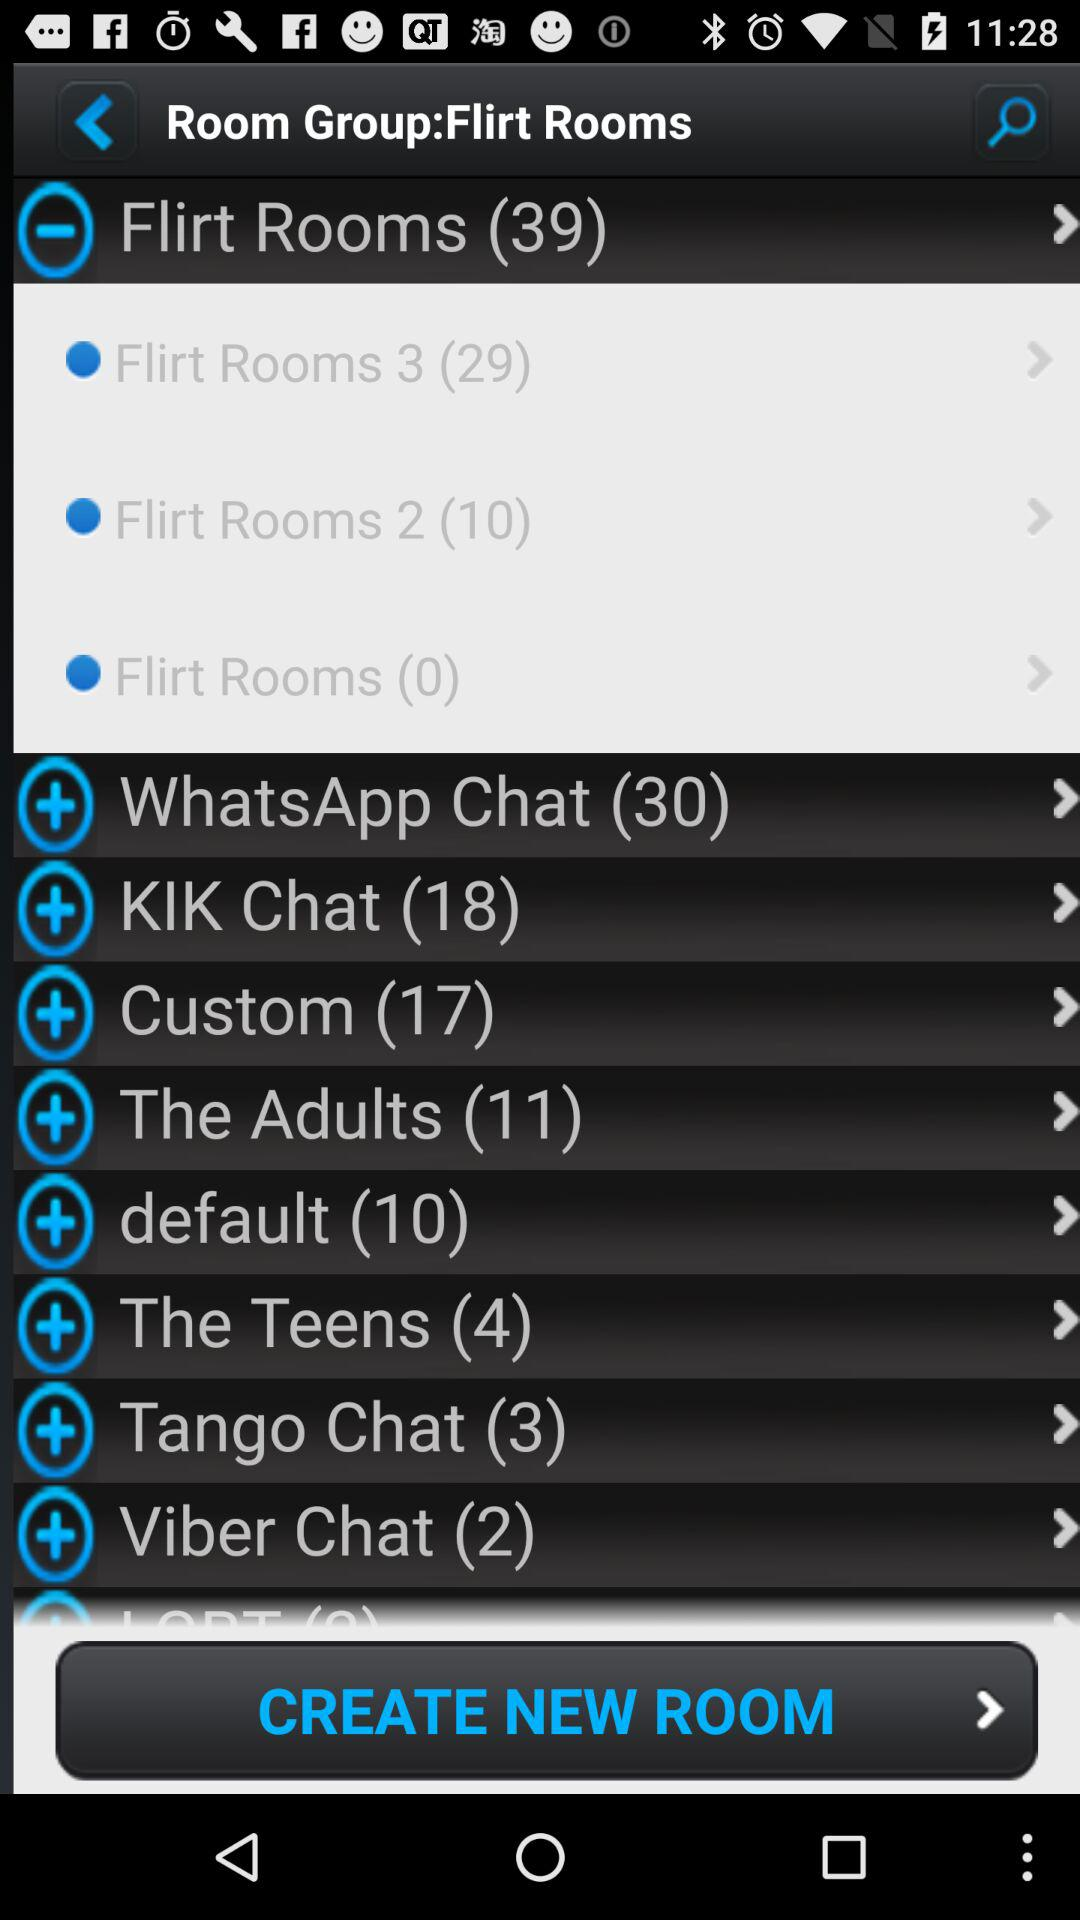How many rooms in total are there in the "Flirt Rooms"? There are 39 rooms in the "Flirt Rooms". 